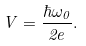<formula> <loc_0><loc_0><loc_500><loc_500>V = \frac { \hbar { \omega } _ { 0 } } { 2 e } .</formula> 